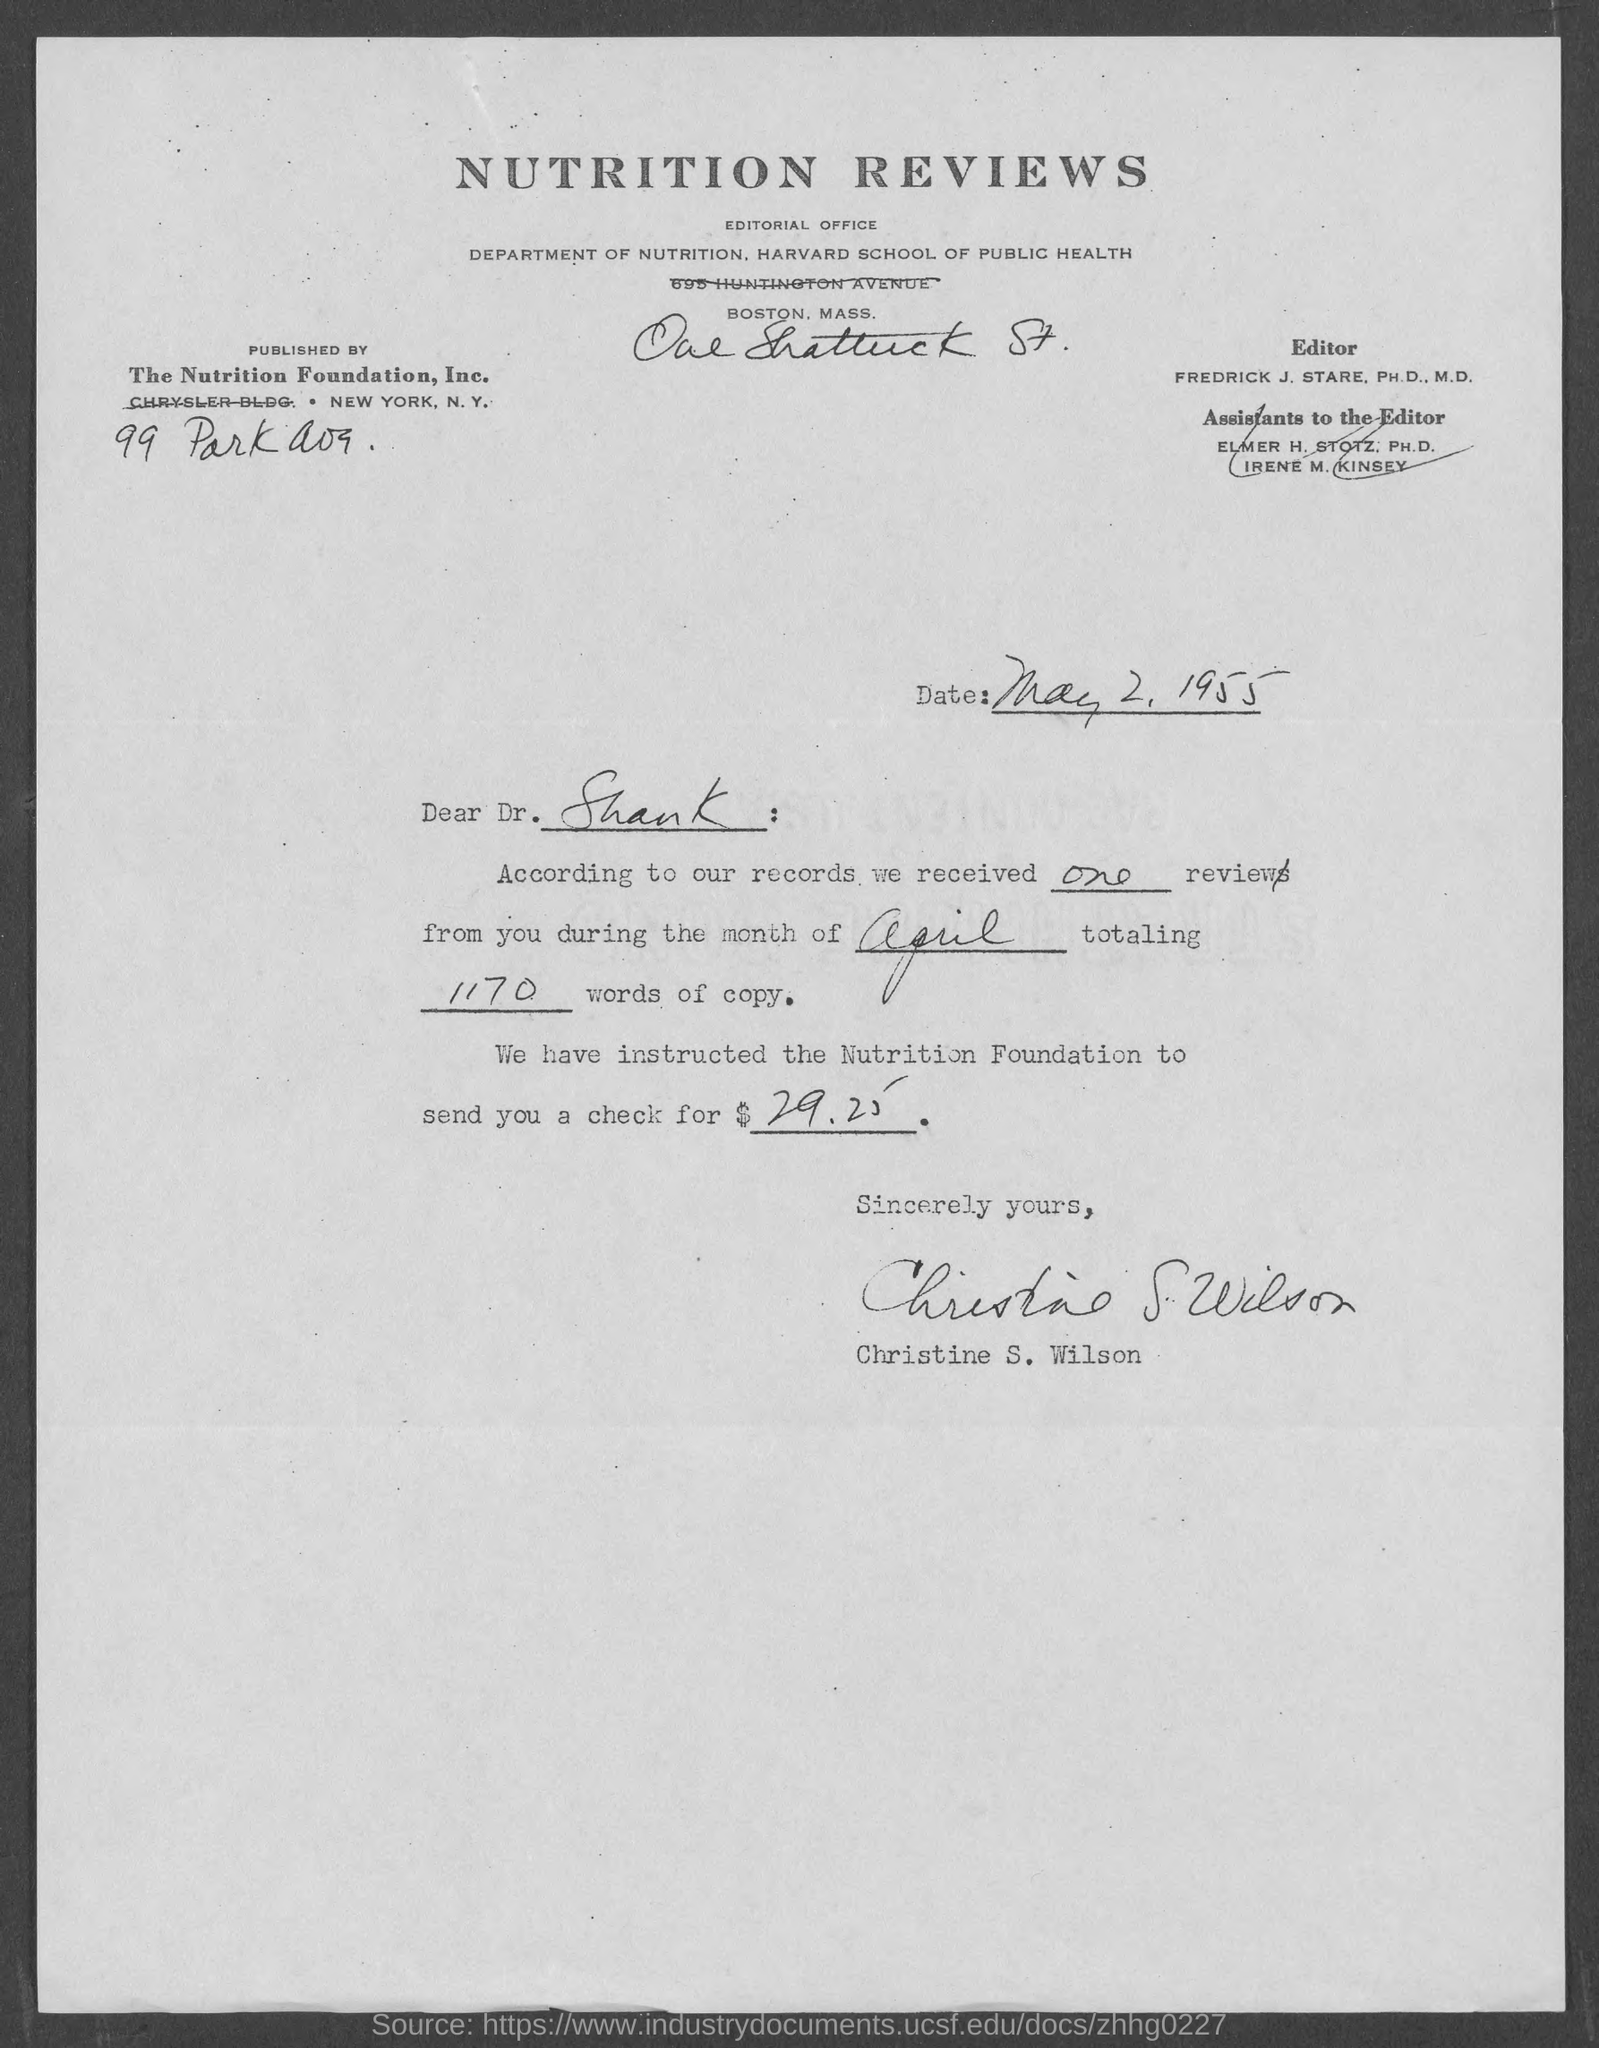What is the Title of the document?
Your answer should be compact. Nutrition Reviews. This was published by whom?
Ensure brevity in your answer.  The Nutrition Foundation, Inc. What is the date on the document?
Your answer should be very brief. May 2, 1955. To Whom is this letter addressed to?
Your response must be concise. Dr. Shank. Who is this letter from?
Offer a very short reply. Christine S. Wilson. Who is the Editor?
Provide a short and direct response. Fredrick J. Stare. How many reviews were received?
Provide a short and direct response. One. How many words of copy?
Your answer should be compact. 1170. What amount was the check for?
Provide a short and direct response. 29.25. 